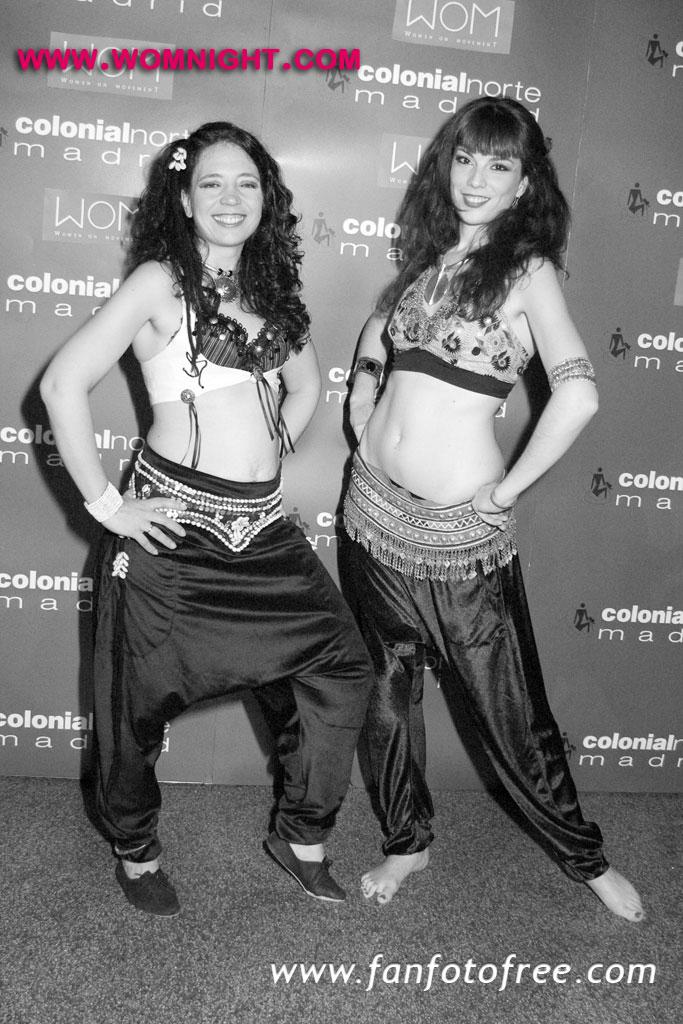How many people are present in the image? There are two persons standing in the image. What is the facial expression of the persons in the image? The persons are smiling. What can be seen in the background of the image? There is a board in the background of the image. Can you describe any additional features of the image? There are watermarks at the top and bottom of the image. What type of plantation can be seen in the background of the image? There is no plantation present in the image; it only features two persons standing and a board in the background. How does the dock contribute to the overall atmosphere of the image? There is no dock present in the image, so it cannot contribute to the atmosphere. 